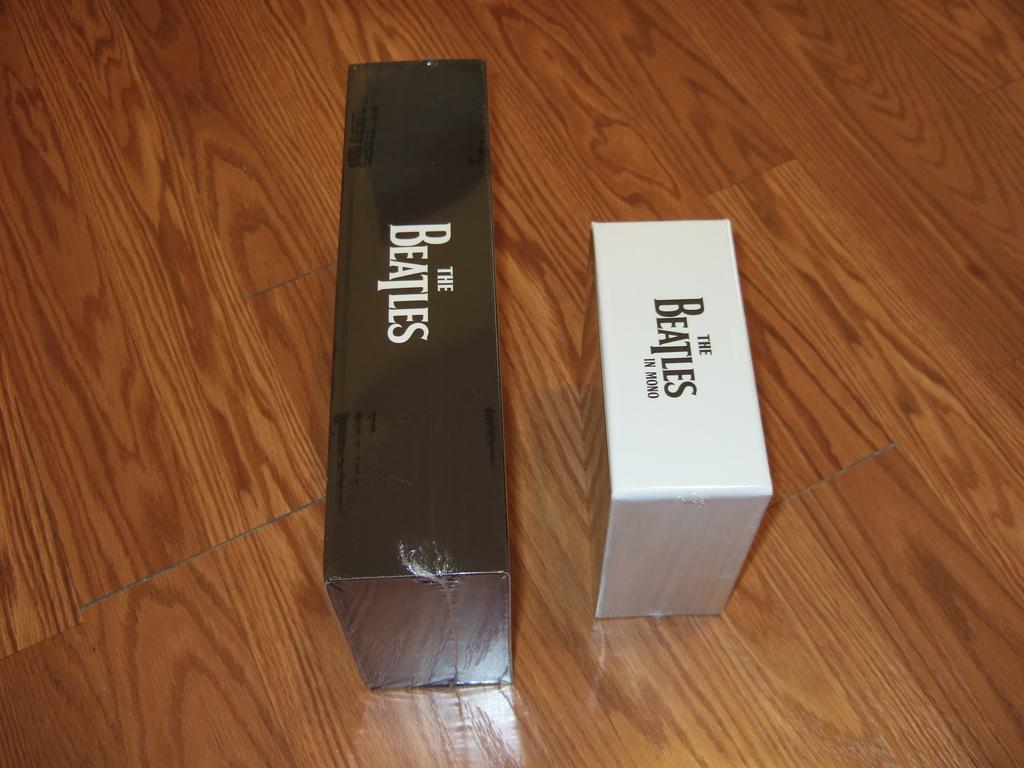<image>
Describe the image concisely. Two Beatles collections, one of which is not in stereo. 